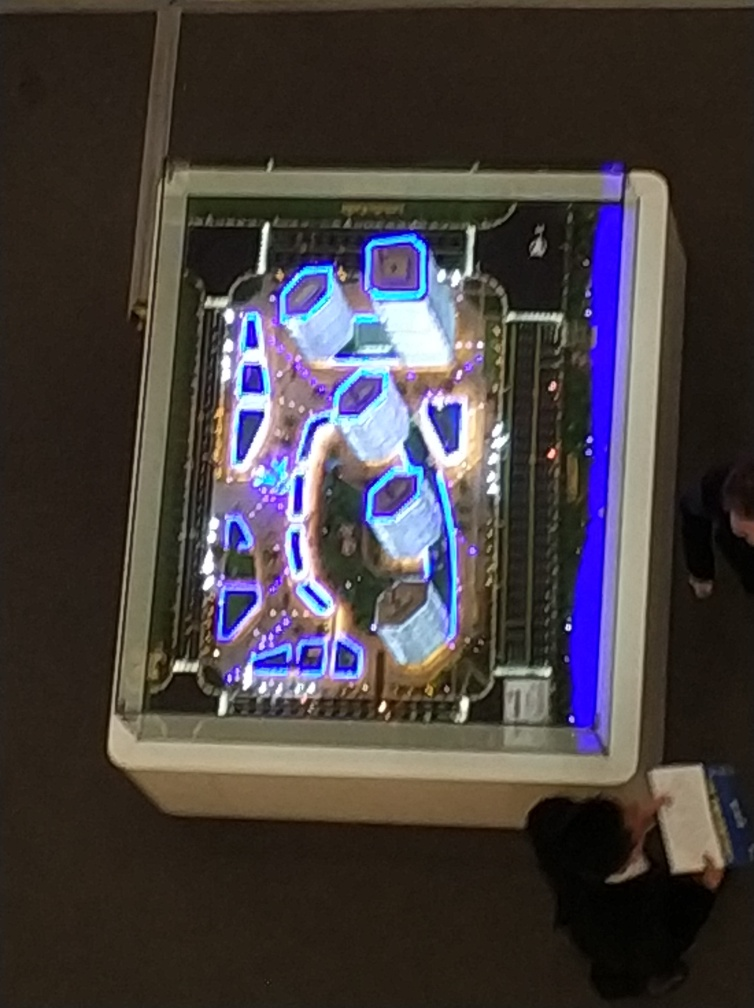Is the background blurry?
 Yes 